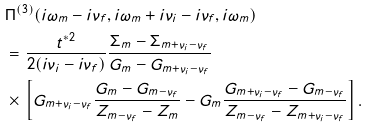Convert formula to latex. <formula><loc_0><loc_0><loc_500><loc_500>& \Pi ^ { ( 3 ) } ( i \omega _ { m } - i \nu _ { f } , i \omega _ { m } + i \nu _ { i } - i \nu _ { f } , i \omega _ { m } ) \\ & = \frac { t ^ { * 2 } } { 2 ( i \nu _ { i } - i \nu _ { f } ) } \frac { \Sigma _ { m } - \Sigma _ { m + \nu _ { i } - \nu _ { f } } } { G _ { m } - G _ { m + \nu _ { i } - \nu _ { f } } } \\ & \times \, \left [ G _ { m + \nu _ { i } - \nu _ { f } } \frac { G _ { m } - G _ { m - \nu _ { f } } } { Z _ { m - \nu _ { f } } - Z _ { m } } - G _ { m } \frac { G _ { m + \nu _ { i } - \nu _ { f } } - G _ { m - \nu _ { f } } } { Z _ { m - \nu _ { f } } - Z _ { m + \nu _ { i } - \nu _ { f } } } \right ] .</formula> 